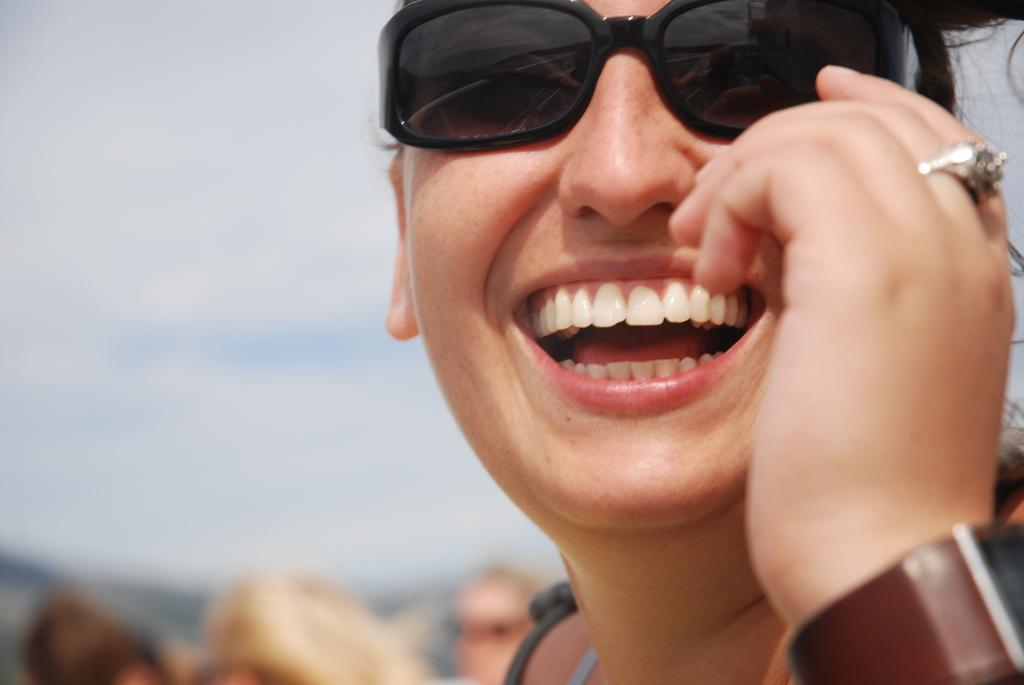Please provide a concise description of this image. In the center of the image we can see a person is smiling and she is wearing glasses. In the background, we can see it is blurred. 